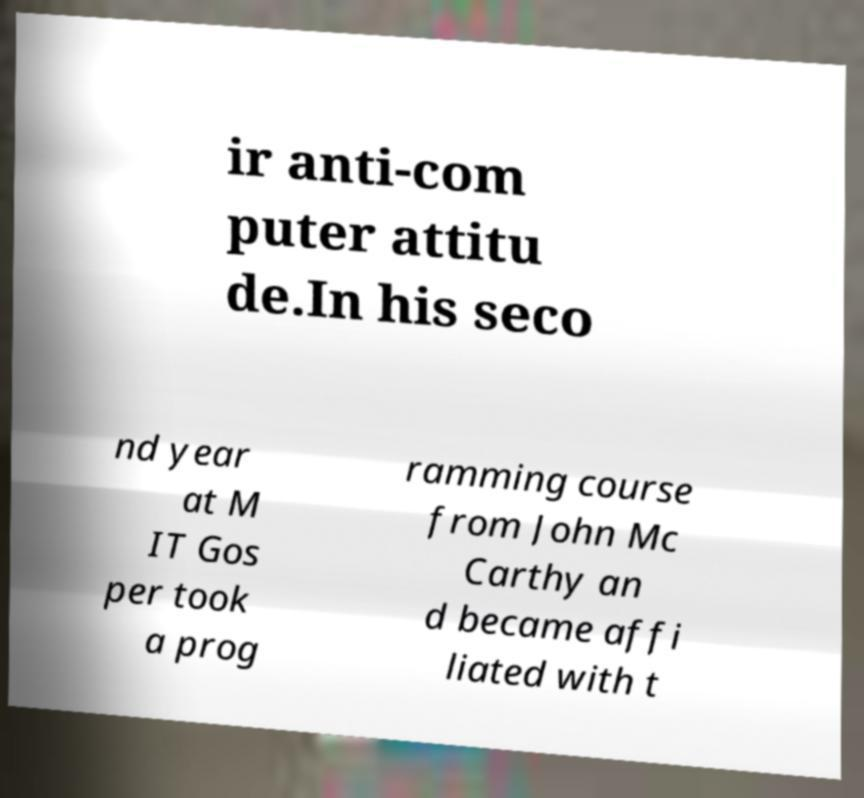Can you accurately transcribe the text from the provided image for me? ir anti-com puter attitu de.In his seco nd year at M IT Gos per took a prog ramming course from John Mc Carthy an d became affi liated with t 